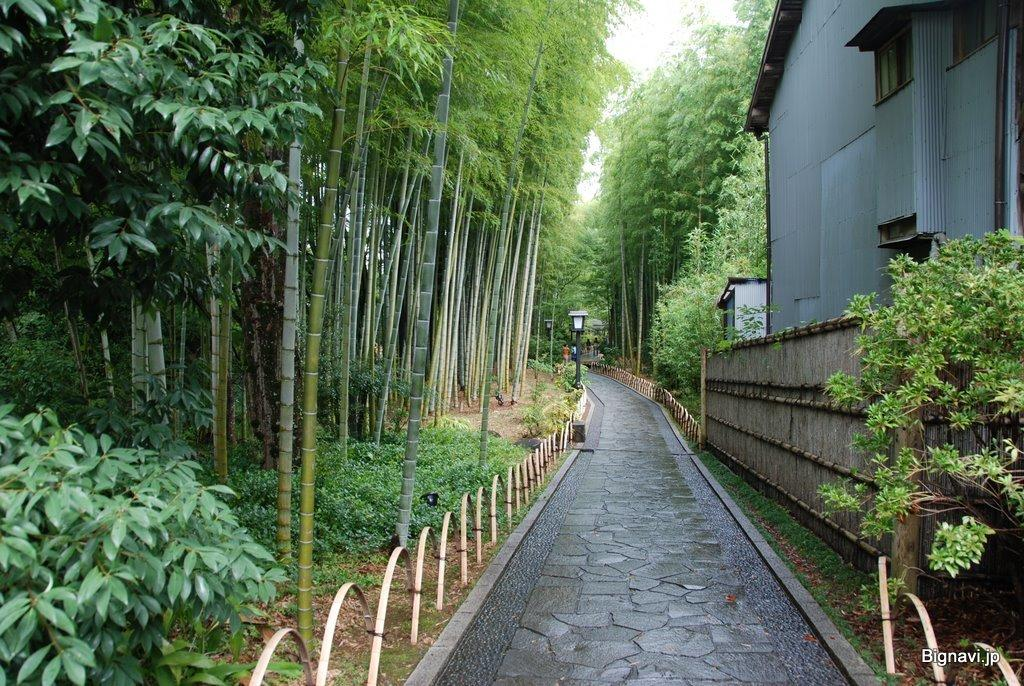What type of vegetation can be seen in the image? There are many trees, plants, and grass in the image. What structures are present in the image? There are railings, fencing, a house, poles with lights, and a walkway in the image. What type of riddle can be seen written on the note in the image? There is no note or riddle present in the image. What type of flesh can be seen hanging from the trees in the image? There is no flesh present in the image; it features trees, plants, and grass. 